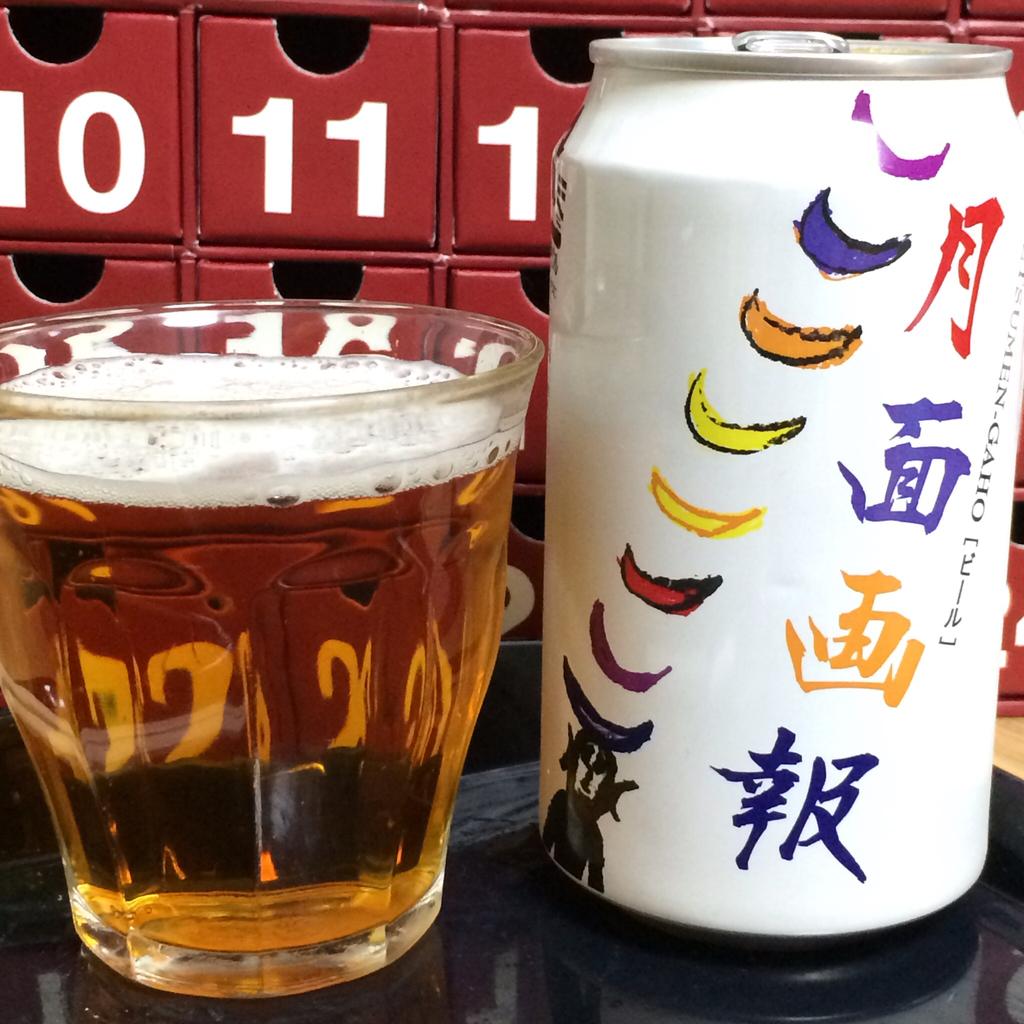What number is in the top left?
Give a very brief answer. 10. 